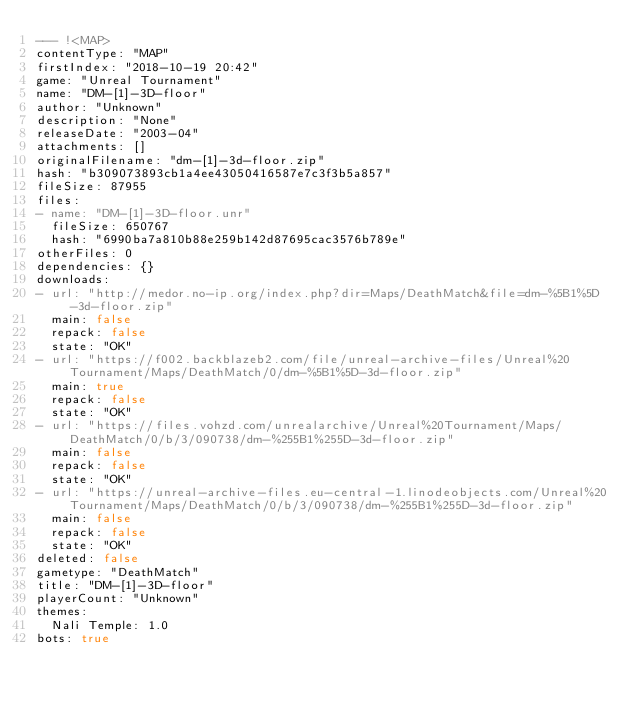<code> <loc_0><loc_0><loc_500><loc_500><_YAML_>--- !<MAP>
contentType: "MAP"
firstIndex: "2018-10-19 20:42"
game: "Unreal Tournament"
name: "DM-[1]-3D-floor"
author: "Unknown"
description: "None"
releaseDate: "2003-04"
attachments: []
originalFilename: "dm-[1]-3d-floor.zip"
hash: "b309073893cb1a4ee43050416587e7c3f3b5a857"
fileSize: 87955
files:
- name: "DM-[1]-3D-floor.unr"
  fileSize: 650767
  hash: "6990ba7a810b88e259b142d87695cac3576b789e"
otherFiles: 0
dependencies: {}
downloads:
- url: "http://medor.no-ip.org/index.php?dir=Maps/DeathMatch&file=dm-%5B1%5D-3d-floor.zip"
  main: false
  repack: false
  state: "OK"
- url: "https://f002.backblazeb2.com/file/unreal-archive-files/Unreal%20Tournament/Maps/DeathMatch/0/dm-%5B1%5D-3d-floor.zip"
  main: true
  repack: false
  state: "OK"
- url: "https://files.vohzd.com/unrealarchive/Unreal%20Tournament/Maps/DeathMatch/0/b/3/090738/dm-%255B1%255D-3d-floor.zip"
  main: false
  repack: false
  state: "OK"
- url: "https://unreal-archive-files.eu-central-1.linodeobjects.com/Unreal%20Tournament/Maps/DeathMatch/0/b/3/090738/dm-%255B1%255D-3d-floor.zip"
  main: false
  repack: false
  state: "OK"
deleted: false
gametype: "DeathMatch"
title: "DM-[1]-3D-floor"
playerCount: "Unknown"
themes:
  Nali Temple: 1.0
bots: true
</code> 